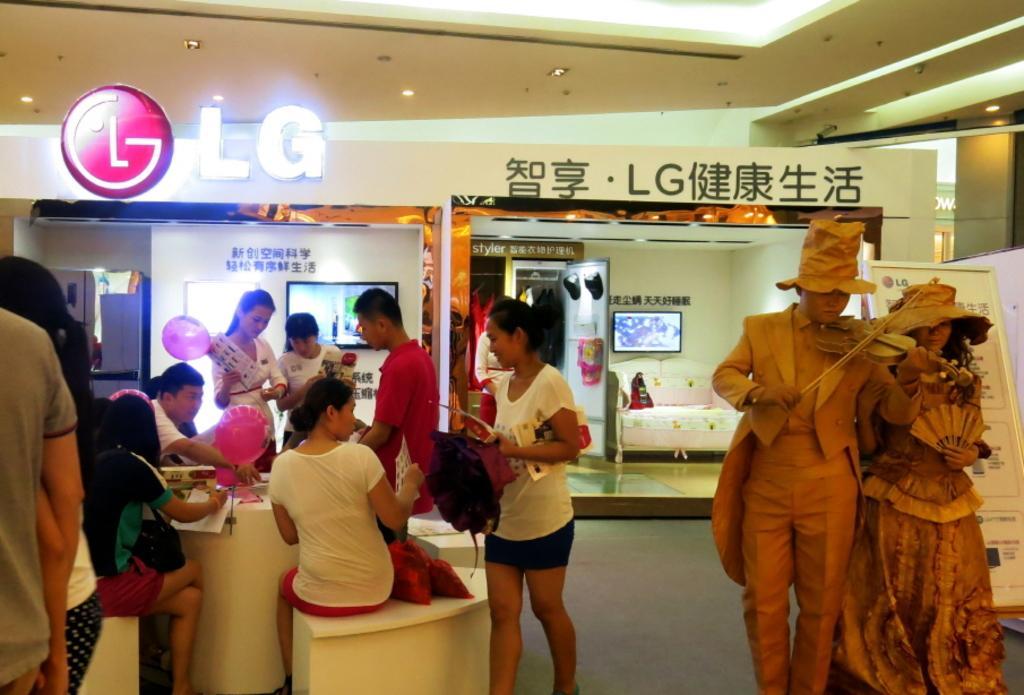Please provide a concise description of this image. An indoor picture. This persons are sitting on table. This persons are standing. This is a statue with guitar. Television on wall. This woman is holding a paper and balloon. On this table there are paper and balloon. A logo of an LG. 